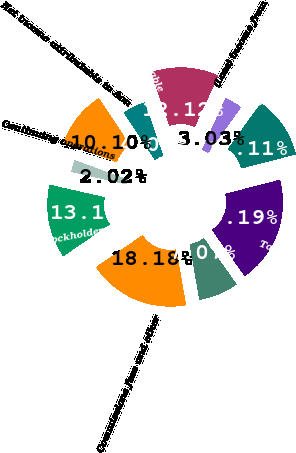Convert chart. <chart><loc_0><loc_0><loc_500><loc_500><pie_chart><fcel>(millions except stockholders<fcel>Commissions fees and other<fcel>Fiduciary investment income<fcel>Total revenue<fcel>Income from continuing<fcel>(Loss) income from<fcel>Net income<fcel>Less Net income attributable<fcel>Net income attributable to Aon<fcel>Continuing operations<nl><fcel>13.13%<fcel>18.18%<fcel>7.07%<fcel>19.19%<fcel>11.11%<fcel>3.03%<fcel>12.12%<fcel>4.04%<fcel>10.1%<fcel>2.02%<nl></chart> 